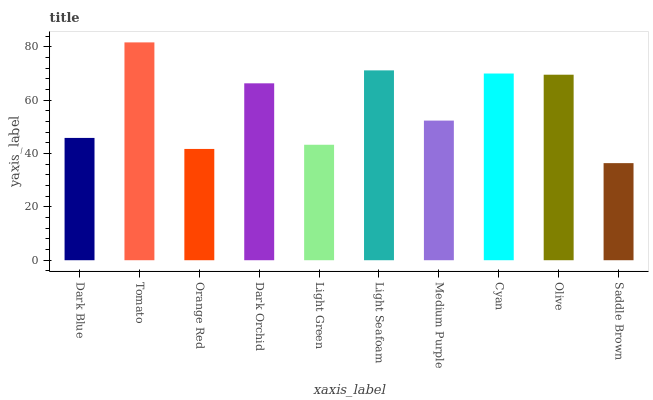Is Saddle Brown the minimum?
Answer yes or no. Yes. Is Tomato the maximum?
Answer yes or no. Yes. Is Orange Red the minimum?
Answer yes or no. No. Is Orange Red the maximum?
Answer yes or no. No. Is Tomato greater than Orange Red?
Answer yes or no. Yes. Is Orange Red less than Tomato?
Answer yes or no. Yes. Is Orange Red greater than Tomato?
Answer yes or no. No. Is Tomato less than Orange Red?
Answer yes or no. No. Is Dark Orchid the high median?
Answer yes or no. Yes. Is Medium Purple the low median?
Answer yes or no. Yes. Is Olive the high median?
Answer yes or no. No. Is Cyan the low median?
Answer yes or no. No. 